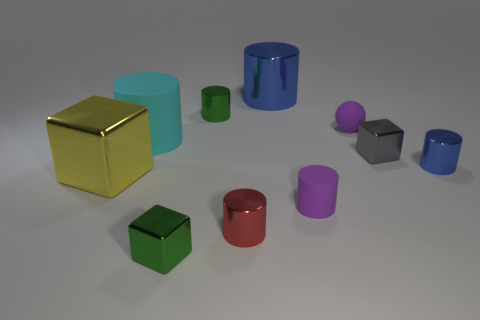Subtract all green cubes. How many cubes are left? 2 Subtract all yellow blocks. How many blocks are left? 2 Subtract 2 cylinders. How many cylinders are left? 4 Subtract all cubes. How many objects are left? 7 Add 7 small green cubes. How many small green cubes exist? 8 Subtract 0 yellow cylinders. How many objects are left? 10 Subtract all red cubes. Subtract all purple spheres. How many cubes are left? 3 Subtract all blue balls. How many gray cubes are left? 1 Subtract all green cylinders. Subtract all large yellow shiny cubes. How many objects are left? 8 Add 3 big yellow metal cubes. How many big yellow metal cubes are left? 4 